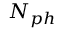<formula> <loc_0><loc_0><loc_500><loc_500>N _ { p h }</formula> 